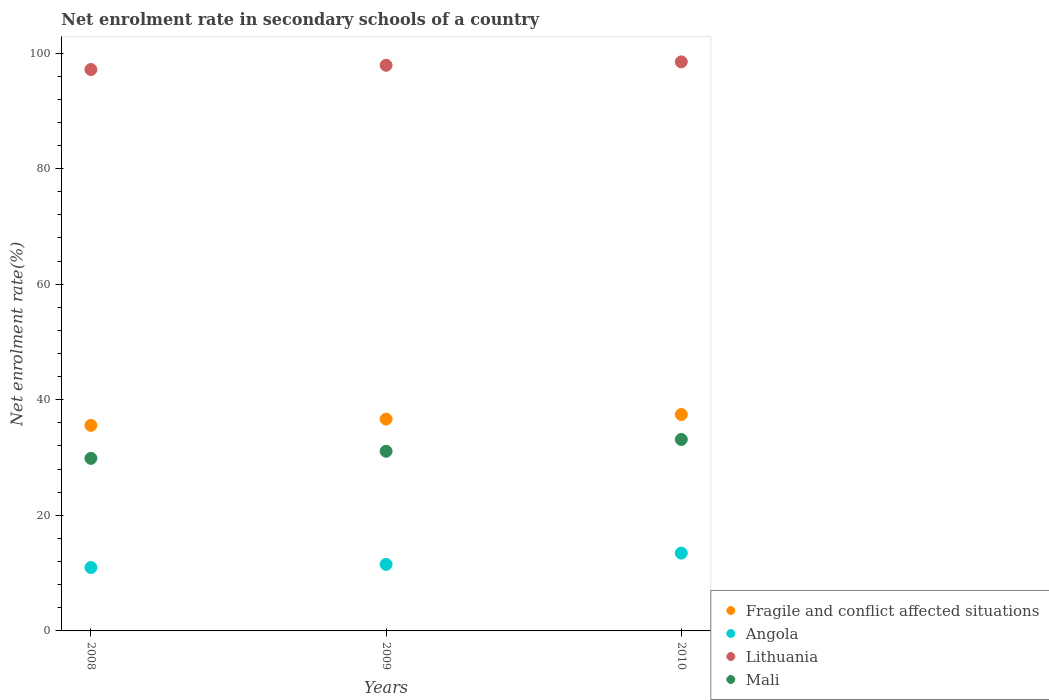What is the net enrolment rate in secondary schools in Fragile and conflict affected situations in 2009?
Your answer should be compact. 36.65. Across all years, what is the maximum net enrolment rate in secondary schools in Angola?
Give a very brief answer. 13.46. Across all years, what is the minimum net enrolment rate in secondary schools in Fragile and conflict affected situations?
Offer a very short reply. 35.57. In which year was the net enrolment rate in secondary schools in Mali minimum?
Your answer should be compact. 2008. What is the total net enrolment rate in secondary schools in Mali in the graph?
Offer a very short reply. 94.08. What is the difference between the net enrolment rate in secondary schools in Angola in 2009 and that in 2010?
Ensure brevity in your answer.  -1.95. What is the difference between the net enrolment rate in secondary schools in Lithuania in 2009 and the net enrolment rate in secondary schools in Fragile and conflict affected situations in 2010?
Offer a very short reply. 60.43. What is the average net enrolment rate in secondary schools in Angola per year?
Your answer should be very brief. 11.98. In the year 2009, what is the difference between the net enrolment rate in secondary schools in Mali and net enrolment rate in secondary schools in Fragile and conflict affected situations?
Keep it short and to the point. -5.57. What is the ratio of the net enrolment rate in secondary schools in Mali in 2008 to that in 2010?
Make the answer very short. 0.9. Is the net enrolment rate in secondary schools in Lithuania in 2008 less than that in 2010?
Provide a short and direct response. Yes. Is the difference between the net enrolment rate in secondary schools in Mali in 2008 and 2009 greater than the difference between the net enrolment rate in secondary schools in Fragile and conflict affected situations in 2008 and 2009?
Your answer should be compact. No. What is the difference between the highest and the second highest net enrolment rate in secondary schools in Mali?
Your response must be concise. 2.05. What is the difference between the highest and the lowest net enrolment rate in secondary schools in Mali?
Offer a very short reply. 3.27. In how many years, is the net enrolment rate in secondary schools in Fragile and conflict affected situations greater than the average net enrolment rate in secondary schools in Fragile and conflict affected situations taken over all years?
Provide a short and direct response. 2. Is the net enrolment rate in secondary schools in Mali strictly greater than the net enrolment rate in secondary schools in Angola over the years?
Make the answer very short. Yes. Is the net enrolment rate in secondary schools in Fragile and conflict affected situations strictly less than the net enrolment rate in secondary schools in Angola over the years?
Offer a very short reply. No. Does the graph contain any zero values?
Provide a short and direct response. No. Does the graph contain grids?
Keep it short and to the point. No. Where does the legend appear in the graph?
Make the answer very short. Bottom right. How are the legend labels stacked?
Make the answer very short. Vertical. What is the title of the graph?
Offer a terse response. Net enrolment rate in secondary schools of a country. Does "Marshall Islands" appear as one of the legend labels in the graph?
Make the answer very short. No. What is the label or title of the X-axis?
Provide a short and direct response. Years. What is the label or title of the Y-axis?
Your response must be concise. Net enrolment rate(%). What is the Net enrolment rate(%) in Fragile and conflict affected situations in 2008?
Your response must be concise. 35.57. What is the Net enrolment rate(%) of Angola in 2008?
Your answer should be very brief. 10.97. What is the Net enrolment rate(%) in Lithuania in 2008?
Provide a succinct answer. 97.15. What is the Net enrolment rate(%) in Mali in 2008?
Your answer should be compact. 29.86. What is the Net enrolment rate(%) in Fragile and conflict affected situations in 2009?
Your response must be concise. 36.65. What is the Net enrolment rate(%) in Angola in 2009?
Make the answer very short. 11.51. What is the Net enrolment rate(%) of Lithuania in 2009?
Keep it short and to the point. 97.88. What is the Net enrolment rate(%) in Mali in 2009?
Your answer should be very brief. 31.09. What is the Net enrolment rate(%) of Fragile and conflict affected situations in 2010?
Your response must be concise. 37.45. What is the Net enrolment rate(%) of Angola in 2010?
Offer a very short reply. 13.46. What is the Net enrolment rate(%) in Lithuania in 2010?
Give a very brief answer. 98.47. What is the Net enrolment rate(%) in Mali in 2010?
Ensure brevity in your answer.  33.13. Across all years, what is the maximum Net enrolment rate(%) in Fragile and conflict affected situations?
Your answer should be very brief. 37.45. Across all years, what is the maximum Net enrolment rate(%) in Angola?
Your answer should be compact. 13.46. Across all years, what is the maximum Net enrolment rate(%) in Lithuania?
Keep it short and to the point. 98.47. Across all years, what is the maximum Net enrolment rate(%) of Mali?
Make the answer very short. 33.13. Across all years, what is the minimum Net enrolment rate(%) of Fragile and conflict affected situations?
Your response must be concise. 35.57. Across all years, what is the minimum Net enrolment rate(%) in Angola?
Ensure brevity in your answer.  10.97. Across all years, what is the minimum Net enrolment rate(%) of Lithuania?
Offer a terse response. 97.15. Across all years, what is the minimum Net enrolment rate(%) of Mali?
Provide a short and direct response. 29.86. What is the total Net enrolment rate(%) in Fragile and conflict affected situations in the graph?
Your answer should be compact. 109.67. What is the total Net enrolment rate(%) in Angola in the graph?
Make the answer very short. 35.95. What is the total Net enrolment rate(%) of Lithuania in the graph?
Make the answer very short. 293.49. What is the total Net enrolment rate(%) in Mali in the graph?
Your response must be concise. 94.08. What is the difference between the Net enrolment rate(%) in Fragile and conflict affected situations in 2008 and that in 2009?
Keep it short and to the point. -1.08. What is the difference between the Net enrolment rate(%) of Angola in 2008 and that in 2009?
Keep it short and to the point. -0.54. What is the difference between the Net enrolment rate(%) of Lithuania in 2008 and that in 2009?
Provide a succinct answer. -0.73. What is the difference between the Net enrolment rate(%) of Mali in 2008 and that in 2009?
Offer a very short reply. -1.23. What is the difference between the Net enrolment rate(%) of Fragile and conflict affected situations in 2008 and that in 2010?
Provide a succinct answer. -1.88. What is the difference between the Net enrolment rate(%) of Angola in 2008 and that in 2010?
Offer a terse response. -2.49. What is the difference between the Net enrolment rate(%) in Lithuania in 2008 and that in 2010?
Give a very brief answer. -1.33. What is the difference between the Net enrolment rate(%) of Mali in 2008 and that in 2010?
Your response must be concise. -3.27. What is the difference between the Net enrolment rate(%) of Fragile and conflict affected situations in 2009 and that in 2010?
Provide a succinct answer. -0.8. What is the difference between the Net enrolment rate(%) in Angola in 2009 and that in 2010?
Your answer should be compact. -1.95. What is the difference between the Net enrolment rate(%) in Lithuania in 2009 and that in 2010?
Your response must be concise. -0.59. What is the difference between the Net enrolment rate(%) of Mali in 2009 and that in 2010?
Provide a succinct answer. -2.05. What is the difference between the Net enrolment rate(%) in Fragile and conflict affected situations in 2008 and the Net enrolment rate(%) in Angola in 2009?
Your response must be concise. 24.05. What is the difference between the Net enrolment rate(%) in Fragile and conflict affected situations in 2008 and the Net enrolment rate(%) in Lithuania in 2009?
Your answer should be compact. -62.31. What is the difference between the Net enrolment rate(%) in Fragile and conflict affected situations in 2008 and the Net enrolment rate(%) in Mali in 2009?
Your response must be concise. 4.48. What is the difference between the Net enrolment rate(%) of Angola in 2008 and the Net enrolment rate(%) of Lithuania in 2009?
Your response must be concise. -86.91. What is the difference between the Net enrolment rate(%) in Angola in 2008 and the Net enrolment rate(%) in Mali in 2009?
Provide a short and direct response. -20.12. What is the difference between the Net enrolment rate(%) in Lithuania in 2008 and the Net enrolment rate(%) in Mali in 2009?
Offer a terse response. 66.06. What is the difference between the Net enrolment rate(%) in Fragile and conflict affected situations in 2008 and the Net enrolment rate(%) in Angola in 2010?
Provide a short and direct response. 22.1. What is the difference between the Net enrolment rate(%) of Fragile and conflict affected situations in 2008 and the Net enrolment rate(%) of Lithuania in 2010?
Offer a very short reply. -62.9. What is the difference between the Net enrolment rate(%) in Fragile and conflict affected situations in 2008 and the Net enrolment rate(%) in Mali in 2010?
Ensure brevity in your answer.  2.44. What is the difference between the Net enrolment rate(%) in Angola in 2008 and the Net enrolment rate(%) in Lithuania in 2010?
Make the answer very short. -87.5. What is the difference between the Net enrolment rate(%) of Angola in 2008 and the Net enrolment rate(%) of Mali in 2010?
Provide a succinct answer. -22.16. What is the difference between the Net enrolment rate(%) in Lithuania in 2008 and the Net enrolment rate(%) in Mali in 2010?
Make the answer very short. 64.01. What is the difference between the Net enrolment rate(%) in Fragile and conflict affected situations in 2009 and the Net enrolment rate(%) in Angola in 2010?
Provide a succinct answer. 23.19. What is the difference between the Net enrolment rate(%) in Fragile and conflict affected situations in 2009 and the Net enrolment rate(%) in Lithuania in 2010?
Make the answer very short. -61.82. What is the difference between the Net enrolment rate(%) in Fragile and conflict affected situations in 2009 and the Net enrolment rate(%) in Mali in 2010?
Your answer should be very brief. 3.52. What is the difference between the Net enrolment rate(%) of Angola in 2009 and the Net enrolment rate(%) of Lithuania in 2010?
Ensure brevity in your answer.  -86.96. What is the difference between the Net enrolment rate(%) of Angola in 2009 and the Net enrolment rate(%) of Mali in 2010?
Your answer should be very brief. -21.62. What is the difference between the Net enrolment rate(%) in Lithuania in 2009 and the Net enrolment rate(%) in Mali in 2010?
Offer a very short reply. 64.74. What is the average Net enrolment rate(%) in Fragile and conflict affected situations per year?
Offer a very short reply. 36.55. What is the average Net enrolment rate(%) in Angola per year?
Offer a very short reply. 11.98. What is the average Net enrolment rate(%) in Lithuania per year?
Give a very brief answer. 97.83. What is the average Net enrolment rate(%) of Mali per year?
Keep it short and to the point. 31.36. In the year 2008, what is the difference between the Net enrolment rate(%) in Fragile and conflict affected situations and Net enrolment rate(%) in Angola?
Provide a succinct answer. 24.6. In the year 2008, what is the difference between the Net enrolment rate(%) in Fragile and conflict affected situations and Net enrolment rate(%) in Lithuania?
Offer a very short reply. -61.58. In the year 2008, what is the difference between the Net enrolment rate(%) in Fragile and conflict affected situations and Net enrolment rate(%) in Mali?
Give a very brief answer. 5.71. In the year 2008, what is the difference between the Net enrolment rate(%) in Angola and Net enrolment rate(%) in Lithuania?
Your answer should be compact. -86.18. In the year 2008, what is the difference between the Net enrolment rate(%) of Angola and Net enrolment rate(%) of Mali?
Offer a terse response. -18.89. In the year 2008, what is the difference between the Net enrolment rate(%) of Lithuania and Net enrolment rate(%) of Mali?
Your answer should be compact. 67.29. In the year 2009, what is the difference between the Net enrolment rate(%) in Fragile and conflict affected situations and Net enrolment rate(%) in Angola?
Make the answer very short. 25.14. In the year 2009, what is the difference between the Net enrolment rate(%) of Fragile and conflict affected situations and Net enrolment rate(%) of Lithuania?
Offer a very short reply. -61.23. In the year 2009, what is the difference between the Net enrolment rate(%) in Fragile and conflict affected situations and Net enrolment rate(%) in Mali?
Offer a very short reply. 5.57. In the year 2009, what is the difference between the Net enrolment rate(%) of Angola and Net enrolment rate(%) of Lithuania?
Offer a very short reply. -86.36. In the year 2009, what is the difference between the Net enrolment rate(%) of Angola and Net enrolment rate(%) of Mali?
Your answer should be very brief. -19.57. In the year 2009, what is the difference between the Net enrolment rate(%) in Lithuania and Net enrolment rate(%) in Mali?
Your answer should be very brief. 66.79. In the year 2010, what is the difference between the Net enrolment rate(%) of Fragile and conflict affected situations and Net enrolment rate(%) of Angola?
Give a very brief answer. 23.98. In the year 2010, what is the difference between the Net enrolment rate(%) of Fragile and conflict affected situations and Net enrolment rate(%) of Lithuania?
Your answer should be compact. -61.02. In the year 2010, what is the difference between the Net enrolment rate(%) of Fragile and conflict affected situations and Net enrolment rate(%) of Mali?
Offer a very short reply. 4.32. In the year 2010, what is the difference between the Net enrolment rate(%) of Angola and Net enrolment rate(%) of Lithuania?
Your answer should be compact. -85.01. In the year 2010, what is the difference between the Net enrolment rate(%) of Angola and Net enrolment rate(%) of Mali?
Your response must be concise. -19.67. In the year 2010, what is the difference between the Net enrolment rate(%) of Lithuania and Net enrolment rate(%) of Mali?
Your response must be concise. 65.34. What is the ratio of the Net enrolment rate(%) of Fragile and conflict affected situations in 2008 to that in 2009?
Your answer should be compact. 0.97. What is the ratio of the Net enrolment rate(%) of Angola in 2008 to that in 2009?
Give a very brief answer. 0.95. What is the ratio of the Net enrolment rate(%) of Lithuania in 2008 to that in 2009?
Your answer should be compact. 0.99. What is the ratio of the Net enrolment rate(%) of Mali in 2008 to that in 2009?
Offer a terse response. 0.96. What is the ratio of the Net enrolment rate(%) in Fragile and conflict affected situations in 2008 to that in 2010?
Your answer should be compact. 0.95. What is the ratio of the Net enrolment rate(%) of Angola in 2008 to that in 2010?
Give a very brief answer. 0.81. What is the ratio of the Net enrolment rate(%) of Lithuania in 2008 to that in 2010?
Make the answer very short. 0.99. What is the ratio of the Net enrolment rate(%) of Mali in 2008 to that in 2010?
Give a very brief answer. 0.9. What is the ratio of the Net enrolment rate(%) of Fragile and conflict affected situations in 2009 to that in 2010?
Give a very brief answer. 0.98. What is the ratio of the Net enrolment rate(%) of Angola in 2009 to that in 2010?
Offer a very short reply. 0.86. What is the ratio of the Net enrolment rate(%) in Lithuania in 2009 to that in 2010?
Provide a short and direct response. 0.99. What is the ratio of the Net enrolment rate(%) of Mali in 2009 to that in 2010?
Give a very brief answer. 0.94. What is the difference between the highest and the second highest Net enrolment rate(%) in Fragile and conflict affected situations?
Offer a very short reply. 0.8. What is the difference between the highest and the second highest Net enrolment rate(%) in Angola?
Your answer should be very brief. 1.95. What is the difference between the highest and the second highest Net enrolment rate(%) in Lithuania?
Offer a terse response. 0.59. What is the difference between the highest and the second highest Net enrolment rate(%) in Mali?
Give a very brief answer. 2.05. What is the difference between the highest and the lowest Net enrolment rate(%) in Fragile and conflict affected situations?
Keep it short and to the point. 1.88. What is the difference between the highest and the lowest Net enrolment rate(%) of Angola?
Provide a short and direct response. 2.49. What is the difference between the highest and the lowest Net enrolment rate(%) in Lithuania?
Keep it short and to the point. 1.33. What is the difference between the highest and the lowest Net enrolment rate(%) in Mali?
Give a very brief answer. 3.27. 